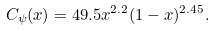<formula> <loc_0><loc_0><loc_500><loc_500>C _ { \psi } ( x ) = 4 9 . 5 x ^ { 2 . 2 } ( 1 - x ) ^ { 2 . 4 5 } .</formula> 